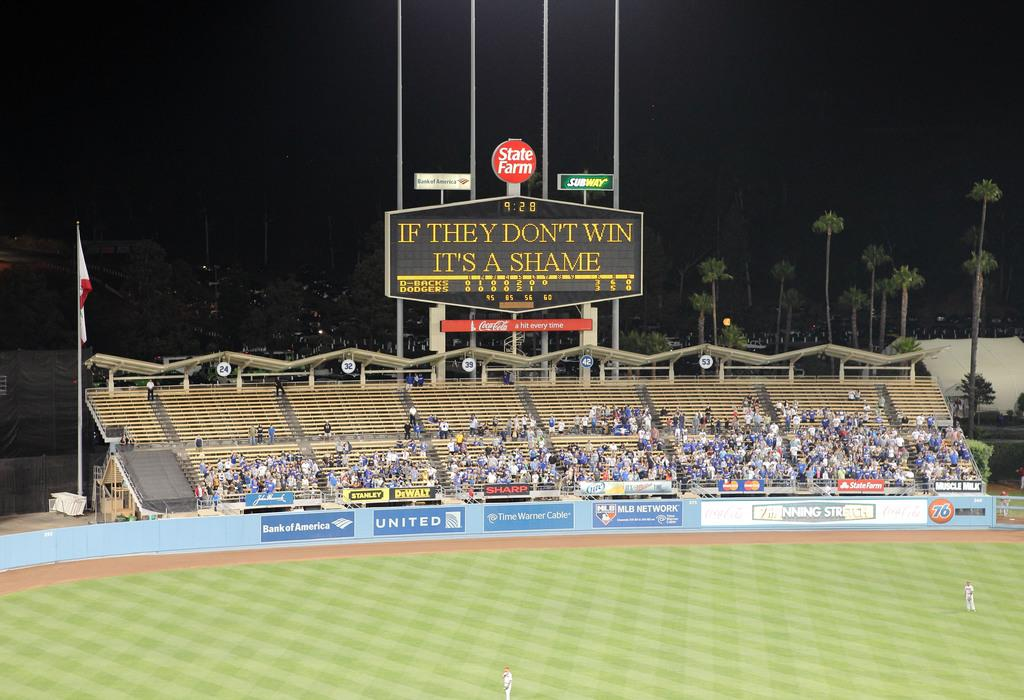What is the main subject of the image? The main subject of the image is a crowd. What objects can be seen in the image besides the crowd? There are boards, a pole, a flag, hoardings, trees, and two persons on the ground visible in the image. What is attached to the pole in the image? A flag is attached to the pole in the image. What type of structures are present in the image? Hoardings are present in the image. What is visible in the background of the image? The sky is visible in the background of the image. What type of debt can be seen on the hoardings in the image? There is no mention of debt in the image, and no such information can be inferred from the provided facts. Can you spot any insects on the trees in the image? There is no mention of insects in the image, and no such information can be inferred from the provided facts. 